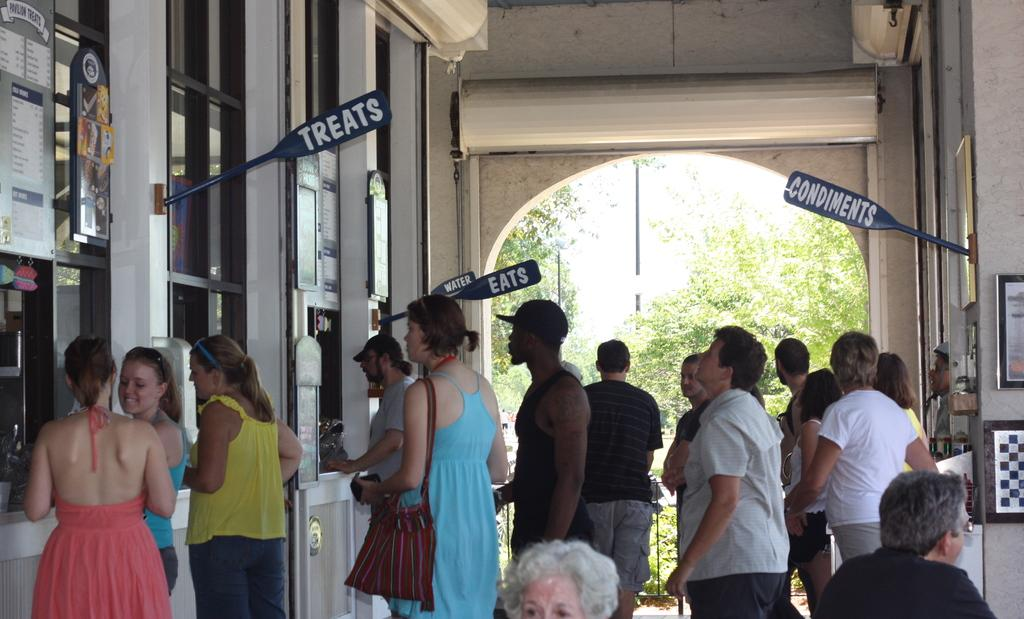What type of establishment is depicted in the image? The image appears to depict a restaurant. How busy is the restaurant in the image? There is a large crowd in front of each stall in the restaurant. What can be seen in the background of the image? Many trees are visible in the background of the image. What time of day is it in the image, and are there any goldfish present? The time of day cannot be determined from the image, and there are no goldfish present. 